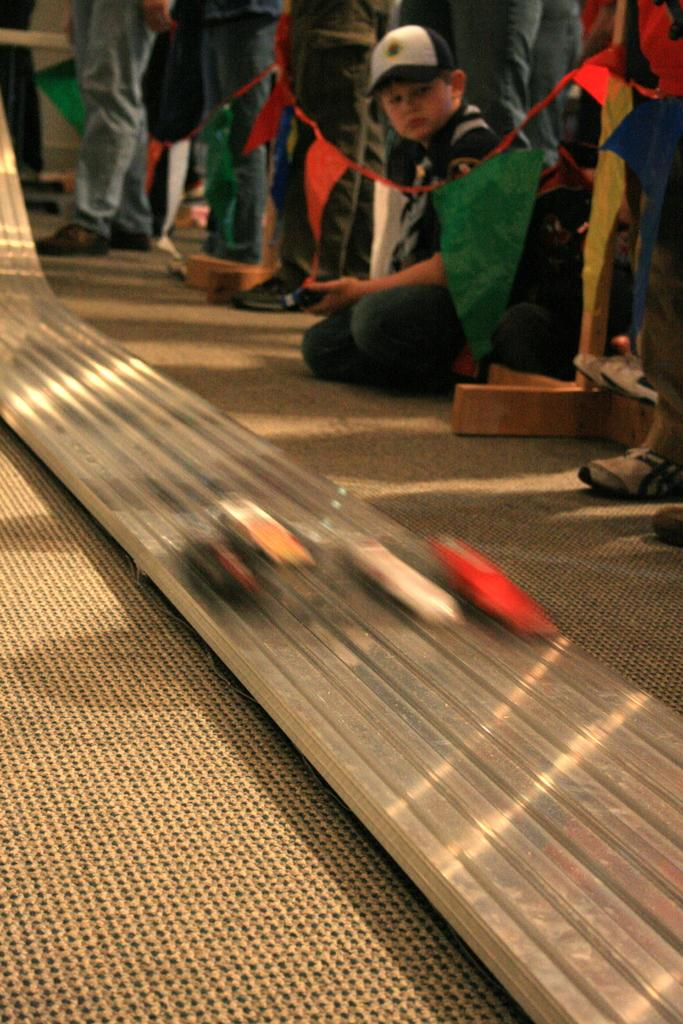What can be seen in the image involving people? There are people standing in the image. What structures are present in the image? There are stands in the image. What decorative elements can be observed in the image? There are flags in the image. What object is on the floor in the image? There is a shield on the floor in the image. What type of connection can be seen between the people in the image? There is no specific connection between the people in the image; they are simply standing. What kind of shade is provided by the flags in the image? The flags in the image are not providing shade; they are decorative elements. 